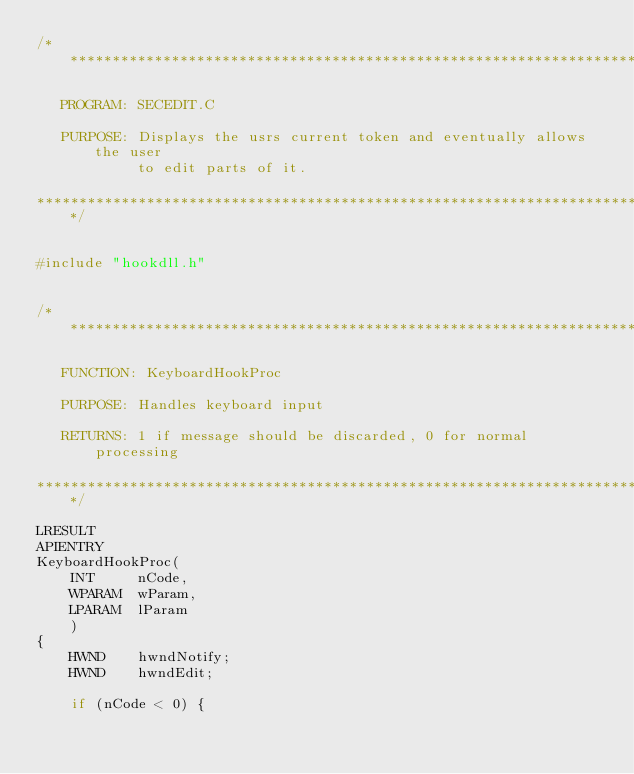Convert code to text. <code><loc_0><loc_0><loc_500><loc_500><_C_>/****************************************************************************

   PROGRAM: SECEDIT.C

   PURPOSE: Displays the usrs current token and eventually allows the user
            to edit parts of it.

****************************************************************************/


#include "hookdll.h"


/****************************************************************************

   FUNCTION: KeyboardHookProc

   PURPOSE: Handles keyboard input

   RETURNS: 1 if message should be discarded, 0 for normal processing

****************************************************************************/

LRESULT
APIENTRY
KeyboardHookProc(
    INT     nCode,
    WPARAM  wParam,
    LPARAM  lParam
    )
{
    HWND    hwndNotify;
    HWND    hwndEdit;

    if (nCode < 0) {</code> 